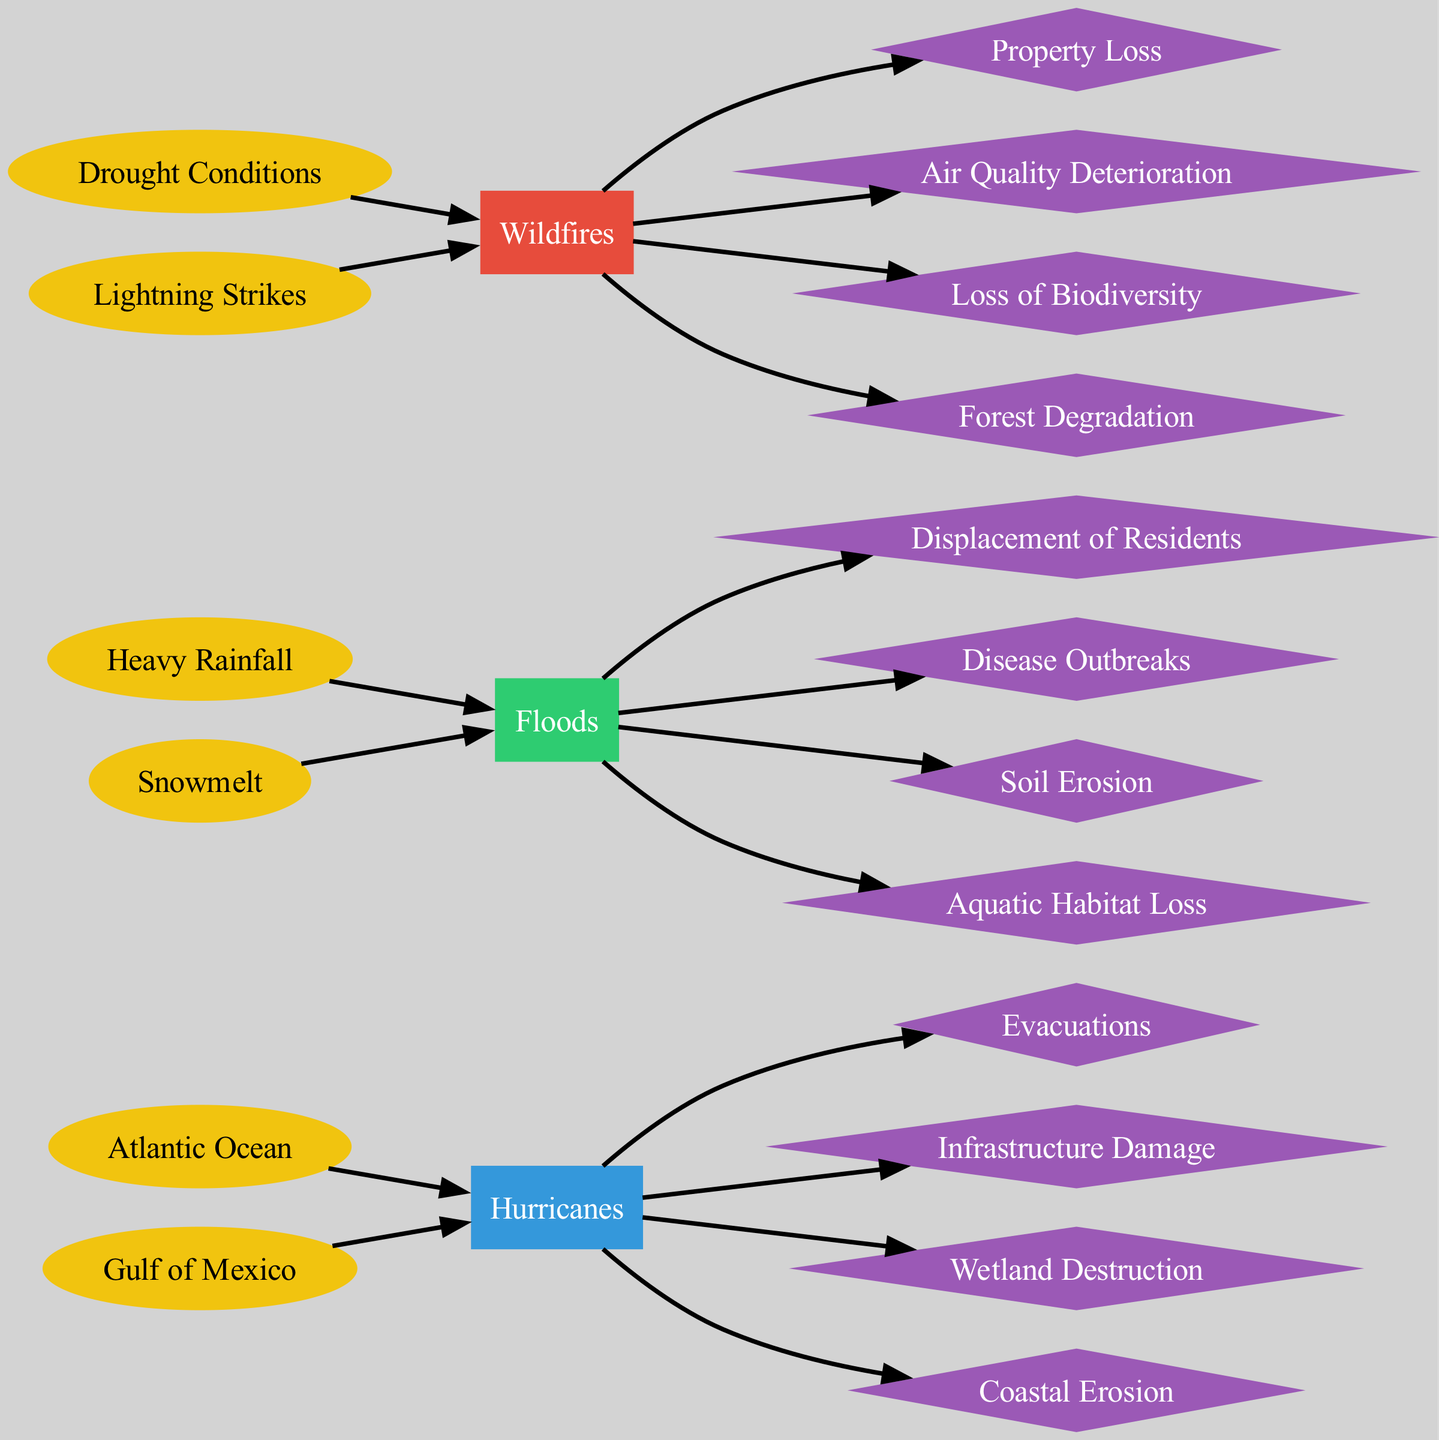What are the two sources of hurricanes depicted in the diagram? The sources of hurricanes listed in the diagram are "Atlantic Ocean" and "Gulf of Mexico." This information can be found under the "hurricanes" section of the diagram.
Answer: Atlantic Ocean, Gulf of Mexico How many impacts on community safety are shown for floods? The impacts on community safety for floods in the diagram include two distinct impacts: "Displacement of Residents" and "Disease Outbreaks." Each impact is represented as a separate node connected to the floods node.
Answer: 2 Which natural disaster has "Air Quality Deterioration" as one of its impacts? The impact "Air Quality Deterioration" is associated with wildfires, as indicated in the diagram. It’s connected to the wildfires node specifically showing its impact.
Answer: Wildfires How many total sources are represented across all types of natural disasters? There are a total of six sources represented: two for hurricanes (Atlantic Ocean, Gulf of Mexico), two for floods (Heavy Rainfall, Snowmelt), and two for wildfires (Drought Conditions, Lightning Strikes). Each source is depicted as a separate node and counted accordingly.
Answer: 6 Which disaster has the highest ecological health impact associated with it? Wildfires have the highest ecological health impacts associated with "Loss of Biodiversity" and "Forest Degradation," which are both shown distinctly connected to the wildfires node. This requires looking at the impacts listed under each disaster type.
Answer: Wildfires What colors represent the impacts in this diagram? The color representing impacts in the diagram is a shade of purple, labeled with the hexadecimal code #9b59b6 in the color scheme. This applies to all impact nodes for hurricanes, floods, and wildfires throughout the diagram.
Answer: Purple How many different types of impacts are shown in the diagram for hurricanes? The types of impacts shown for hurricanes in the diagram are "Evacuations," "Infrastructure Damage," "Wetland Destruction," and "Coastal Erosion," totaling four different impacts. Each impact node is distinctly connected back to the hurricanes node.
Answer: 4 Which source leads to the community safety impact of "Property Loss"? The source leading to "Property Loss" is "Drought Conditions," which is directly connected to the wildfires node, implying a cause-effect relationship that links drought with this specific safety impact.
Answer: Drought Conditions What is the main ecological health impact caused by floods? The main ecological health impacts caused by floods are "Soil Erosion" and "Aquatic Habitat Loss," both of which are listed under the floods section as significant ecological impacts.
Answer: Soil Erosion, Aquatic Habitat Loss 